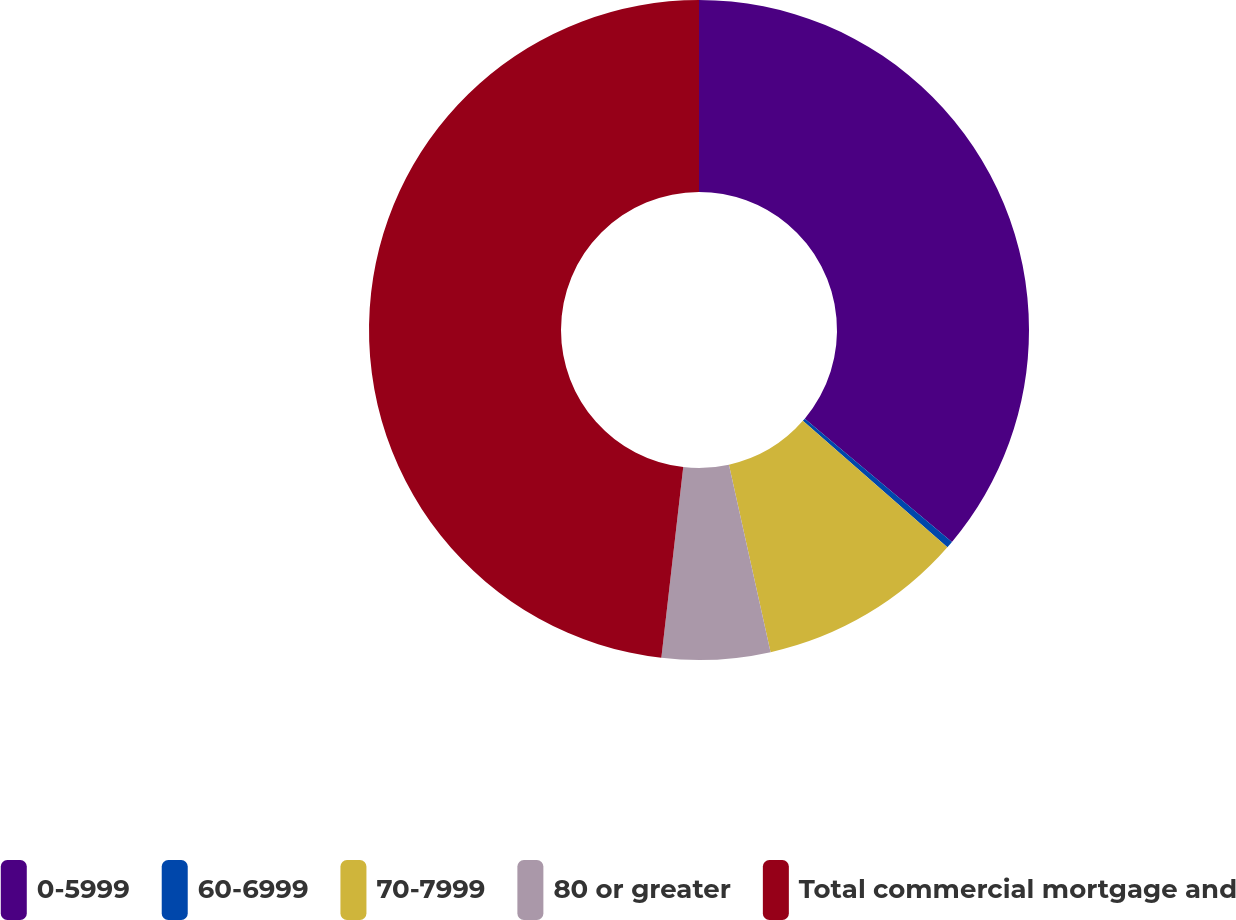Convert chart to OTSL. <chart><loc_0><loc_0><loc_500><loc_500><pie_chart><fcel>0-5999<fcel>60-6999<fcel>70-7999<fcel>80 or greater<fcel>Total commercial mortgage and<nl><fcel>36.1%<fcel>0.34%<fcel>10.08%<fcel>5.3%<fcel>48.18%<nl></chart> 